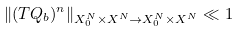Convert formula to latex. <formula><loc_0><loc_0><loc_500><loc_500>\| ( T Q _ { b } ) ^ { n } \| _ { X _ { 0 } ^ { N } \times X ^ { N } \to X _ { 0 } ^ { N } \times X ^ { N } } \ll 1</formula> 